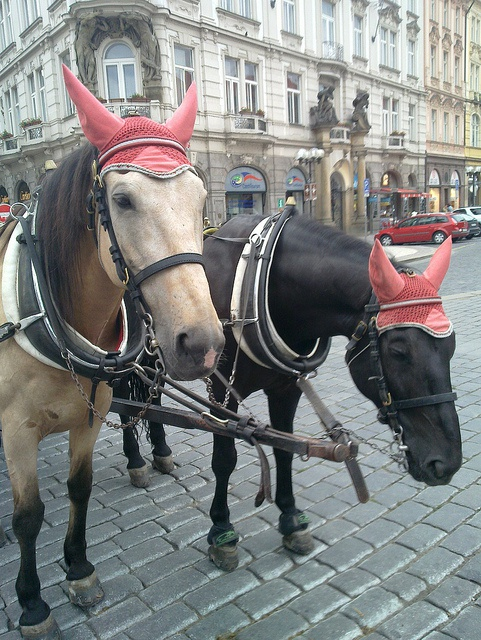Describe the objects in this image and their specific colors. I can see horse in darkgray, gray, black, and lightgray tones, horse in darkgray, black, gray, and brown tones, car in darkgray, brown, and gray tones, car in darkgray, white, and gray tones, and car in darkgray, gray, white, and black tones in this image. 